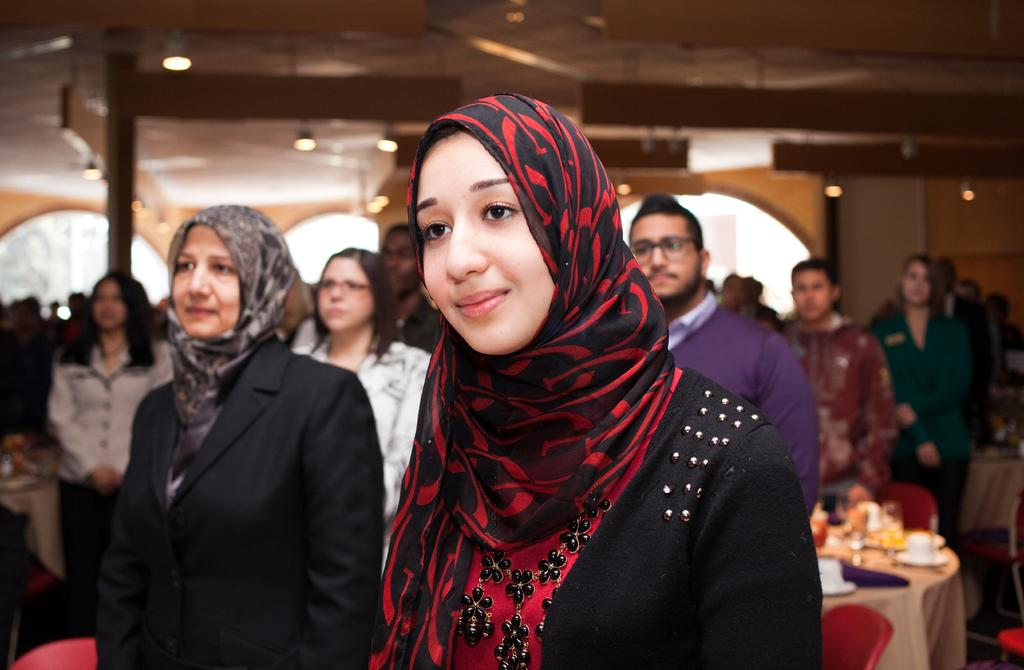How many people are in the image? There is a group of people in the image, but the exact number cannot be determined from the provided facts. What type of furniture is present in the image? There are tables in the image. What can be seen in the glasses in the image? The contents of the glasses cannot be determined from the provided facts. What is the nature of the additional objects in the background of the image? There are some objects and lights in the background of the image, but their specific nature cannot be determined from the provided facts. What is the architectural feature visible in the background of the image? There is a roof in the background of the image. What type of mask is being worn by the person in the image? There is no mention of a mask or any person wearing a mask in the provided facts, so it cannot be determined from the image. 